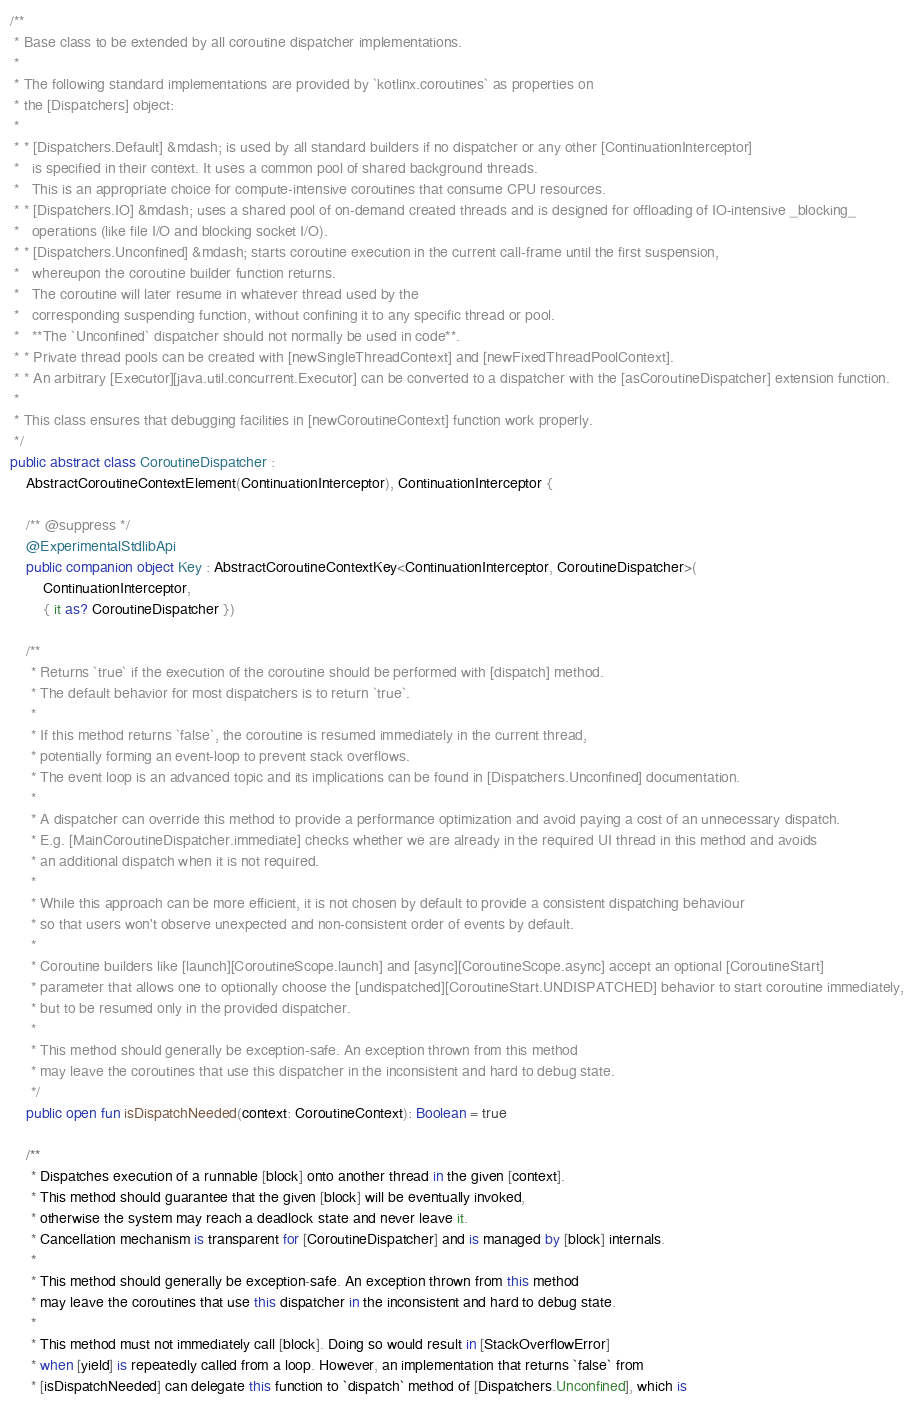Convert code to text. <code><loc_0><loc_0><loc_500><loc_500><_Kotlin_>
/**
 * Base class to be extended by all coroutine dispatcher implementations.
 *
 * The following standard implementations are provided by `kotlinx.coroutines` as properties on
 * the [Dispatchers] object:
 *
 * * [Dispatchers.Default] &mdash; is used by all standard builders if no dispatcher or any other [ContinuationInterceptor]
 *   is specified in their context. It uses a common pool of shared background threads.
 *   This is an appropriate choice for compute-intensive coroutines that consume CPU resources.
 * * [Dispatchers.IO] &mdash; uses a shared pool of on-demand created threads and is designed for offloading of IO-intensive _blocking_
 *   operations (like file I/O and blocking socket I/O).
 * * [Dispatchers.Unconfined] &mdash; starts coroutine execution in the current call-frame until the first suspension,
 *   whereupon the coroutine builder function returns.
 *   The coroutine will later resume in whatever thread used by the
 *   corresponding suspending function, without confining it to any specific thread or pool.
 *   **The `Unconfined` dispatcher should not normally be used in code**.
 * * Private thread pools can be created with [newSingleThreadContext] and [newFixedThreadPoolContext].
 * * An arbitrary [Executor][java.util.concurrent.Executor] can be converted to a dispatcher with the [asCoroutineDispatcher] extension function.
 *
 * This class ensures that debugging facilities in [newCoroutineContext] function work properly.
 */
public abstract class CoroutineDispatcher :
    AbstractCoroutineContextElement(ContinuationInterceptor), ContinuationInterceptor {

    /** @suppress */
    @ExperimentalStdlibApi
    public companion object Key : AbstractCoroutineContextKey<ContinuationInterceptor, CoroutineDispatcher>(
        ContinuationInterceptor,
        { it as? CoroutineDispatcher })

    /**
     * Returns `true` if the execution of the coroutine should be performed with [dispatch] method.
     * The default behavior for most dispatchers is to return `true`.
     *
     * If this method returns `false`, the coroutine is resumed immediately in the current thread,
     * potentially forming an event-loop to prevent stack overflows.
     * The event loop is an advanced topic and its implications can be found in [Dispatchers.Unconfined] documentation.
     *
     * A dispatcher can override this method to provide a performance optimization and avoid paying a cost of an unnecessary dispatch.
     * E.g. [MainCoroutineDispatcher.immediate] checks whether we are already in the required UI thread in this method and avoids
     * an additional dispatch when it is not required.
     *
     * While this approach can be more efficient, it is not chosen by default to provide a consistent dispatching behaviour
     * so that users won't observe unexpected and non-consistent order of events by default.
     *
     * Coroutine builders like [launch][CoroutineScope.launch] and [async][CoroutineScope.async] accept an optional [CoroutineStart]
     * parameter that allows one to optionally choose the [undispatched][CoroutineStart.UNDISPATCHED] behavior to start coroutine immediately,
     * but to be resumed only in the provided dispatcher.
     *
     * This method should generally be exception-safe. An exception thrown from this method
     * may leave the coroutines that use this dispatcher in the inconsistent and hard to debug state.
     */
    public open fun isDispatchNeeded(context: CoroutineContext): Boolean = true

    /**
     * Dispatches execution of a runnable [block] onto another thread in the given [context].
     * This method should guarantee that the given [block] will be eventually invoked,
     * otherwise the system may reach a deadlock state and never leave it.
     * Cancellation mechanism is transparent for [CoroutineDispatcher] and is managed by [block] internals.
     *
     * This method should generally be exception-safe. An exception thrown from this method
     * may leave the coroutines that use this dispatcher in the inconsistent and hard to debug state.
     *
     * This method must not immediately call [block]. Doing so would result in [StackOverflowError]
     * when [yield] is repeatedly called from a loop. However, an implementation that returns `false` from
     * [isDispatchNeeded] can delegate this function to `dispatch` method of [Dispatchers.Unconfined], which is</code> 